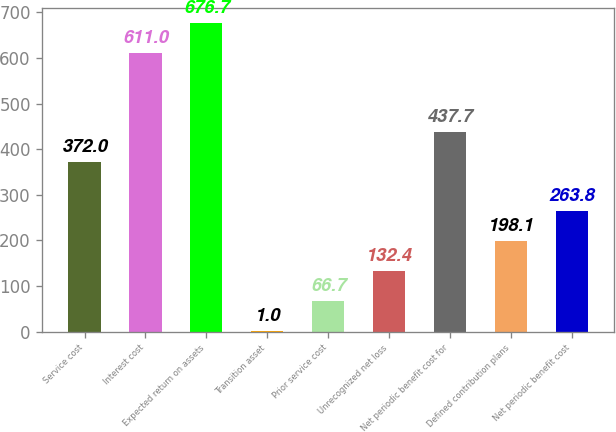Convert chart to OTSL. <chart><loc_0><loc_0><loc_500><loc_500><bar_chart><fcel>Service cost<fcel>Interest cost<fcel>Expected return on assets<fcel>Transition asset<fcel>Prior service cost<fcel>Unrecognized net loss<fcel>Net periodic benefit cost for<fcel>Defined contribution plans<fcel>Net periodic benefit cost<nl><fcel>372<fcel>611<fcel>676.7<fcel>1<fcel>66.7<fcel>132.4<fcel>437.7<fcel>198.1<fcel>263.8<nl></chart> 